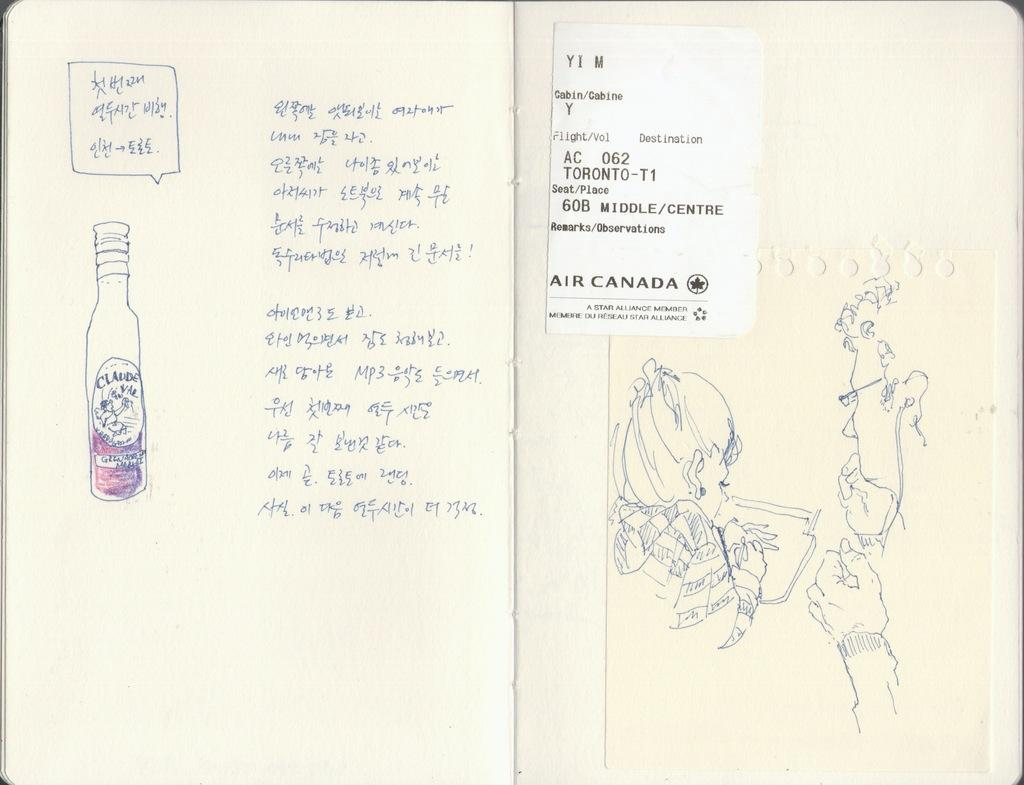Provide a one-sentence caption for the provided image. Foreign hand writing next to a hand drawn bottle and the other page has a hand drawn woman drawing. 